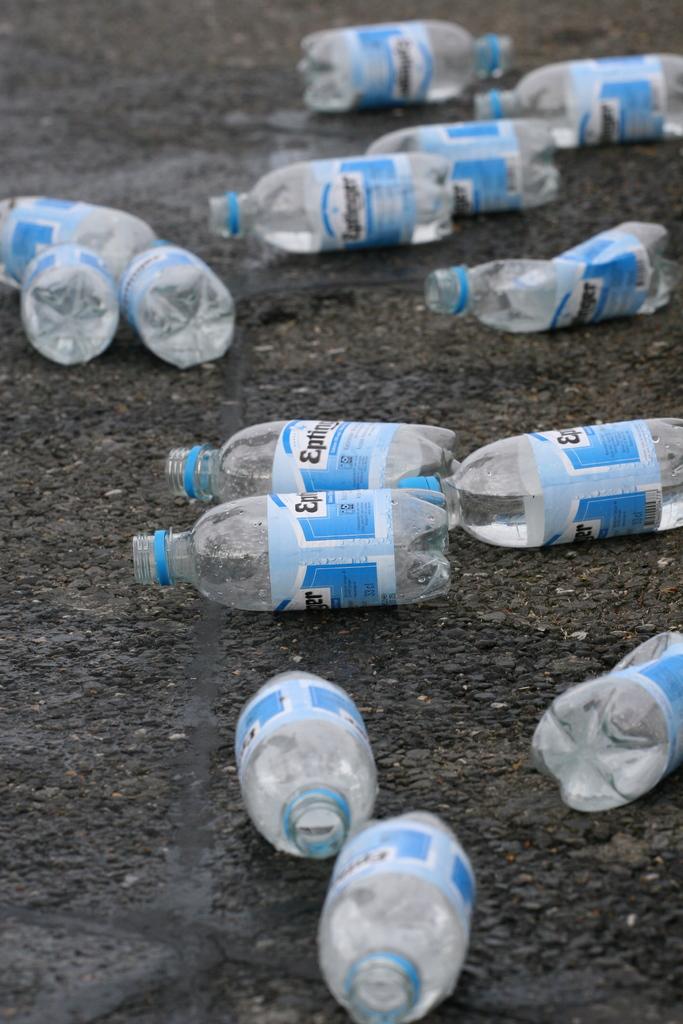What was in the bottles?
Your answer should be very brief. Water. What was the brand name of the bottle?
Your response must be concise. Unanswerable. 